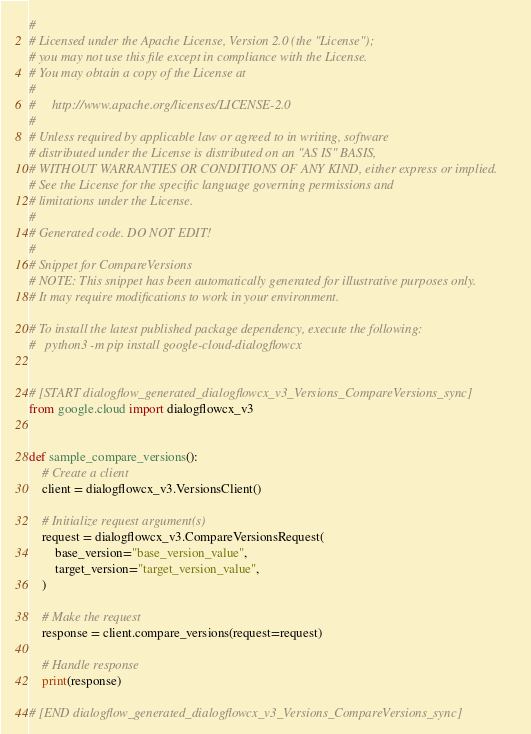<code> <loc_0><loc_0><loc_500><loc_500><_Python_>#
# Licensed under the Apache License, Version 2.0 (the "License");
# you may not use this file except in compliance with the License.
# You may obtain a copy of the License at
#
#     http://www.apache.org/licenses/LICENSE-2.0
#
# Unless required by applicable law or agreed to in writing, software
# distributed under the License is distributed on an "AS IS" BASIS,
# WITHOUT WARRANTIES OR CONDITIONS OF ANY KIND, either express or implied.
# See the License for the specific language governing permissions and
# limitations under the License.
#
# Generated code. DO NOT EDIT!
#
# Snippet for CompareVersions
# NOTE: This snippet has been automatically generated for illustrative purposes only.
# It may require modifications to work in your environment.

# To install the latest published package dependency, execute the following:
#   python3 -m pip install google-cloud-dialogflowcx


# [START dialogflow_generated_dialogflowcx_v3_Versions_CompareVersions_sync]
from google.cloud import dialogflowcx_v3


def sample_compare_versions():
    # Create a client
    client = dialogflowcx_v3.VersionsClient()

    # Initialize request argument(s)
    request = dialogflowcx_v3.CompareVersionsRequest(
        base_version="base_version_value",
        target_version="target_version_value",
    )

    # Make the request
    response = client.compare_versions(request=request)

    # Handle response
    print(response)

# [END dialogflow_generated_dialogflowcx_v3_Versions_CompareVersions_sync]
</code> 